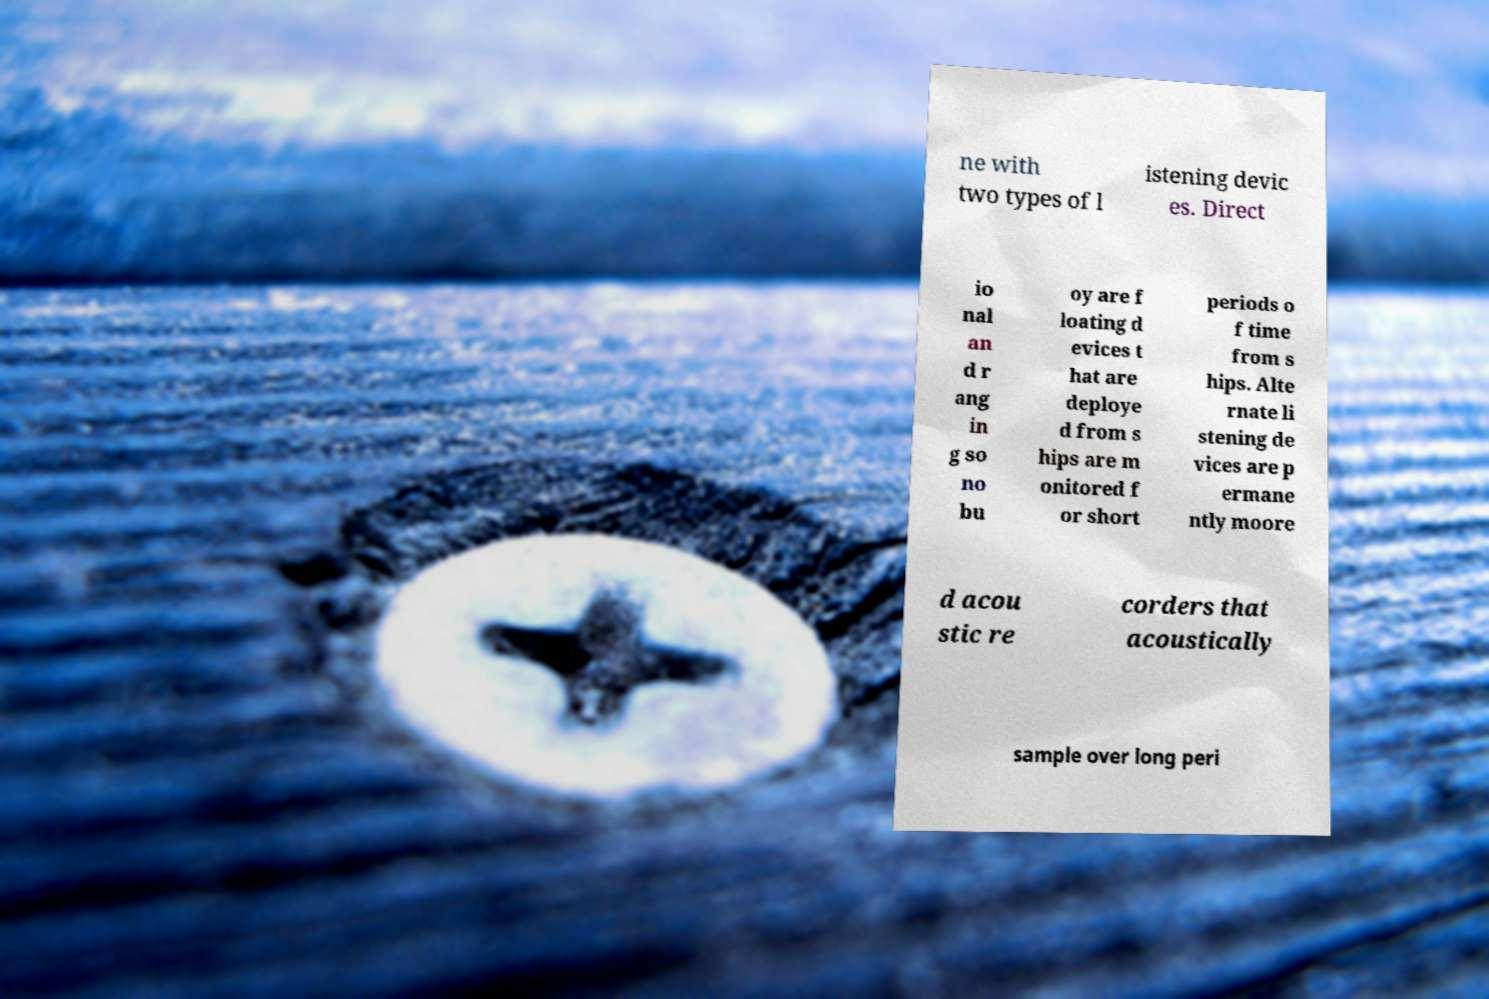Can you accurately transcribe the text from the provided image for me? ne with two types of l istening devic es. Direct io nal an d r ang in g so no bu oy are f loating d evices t hat are deploye d from s hips are m onitored f or short periods o f time from s hips. Alte rnate li stening de vices are p ermane ntly moore d acou stic re corders that acoustically sample over long peri 